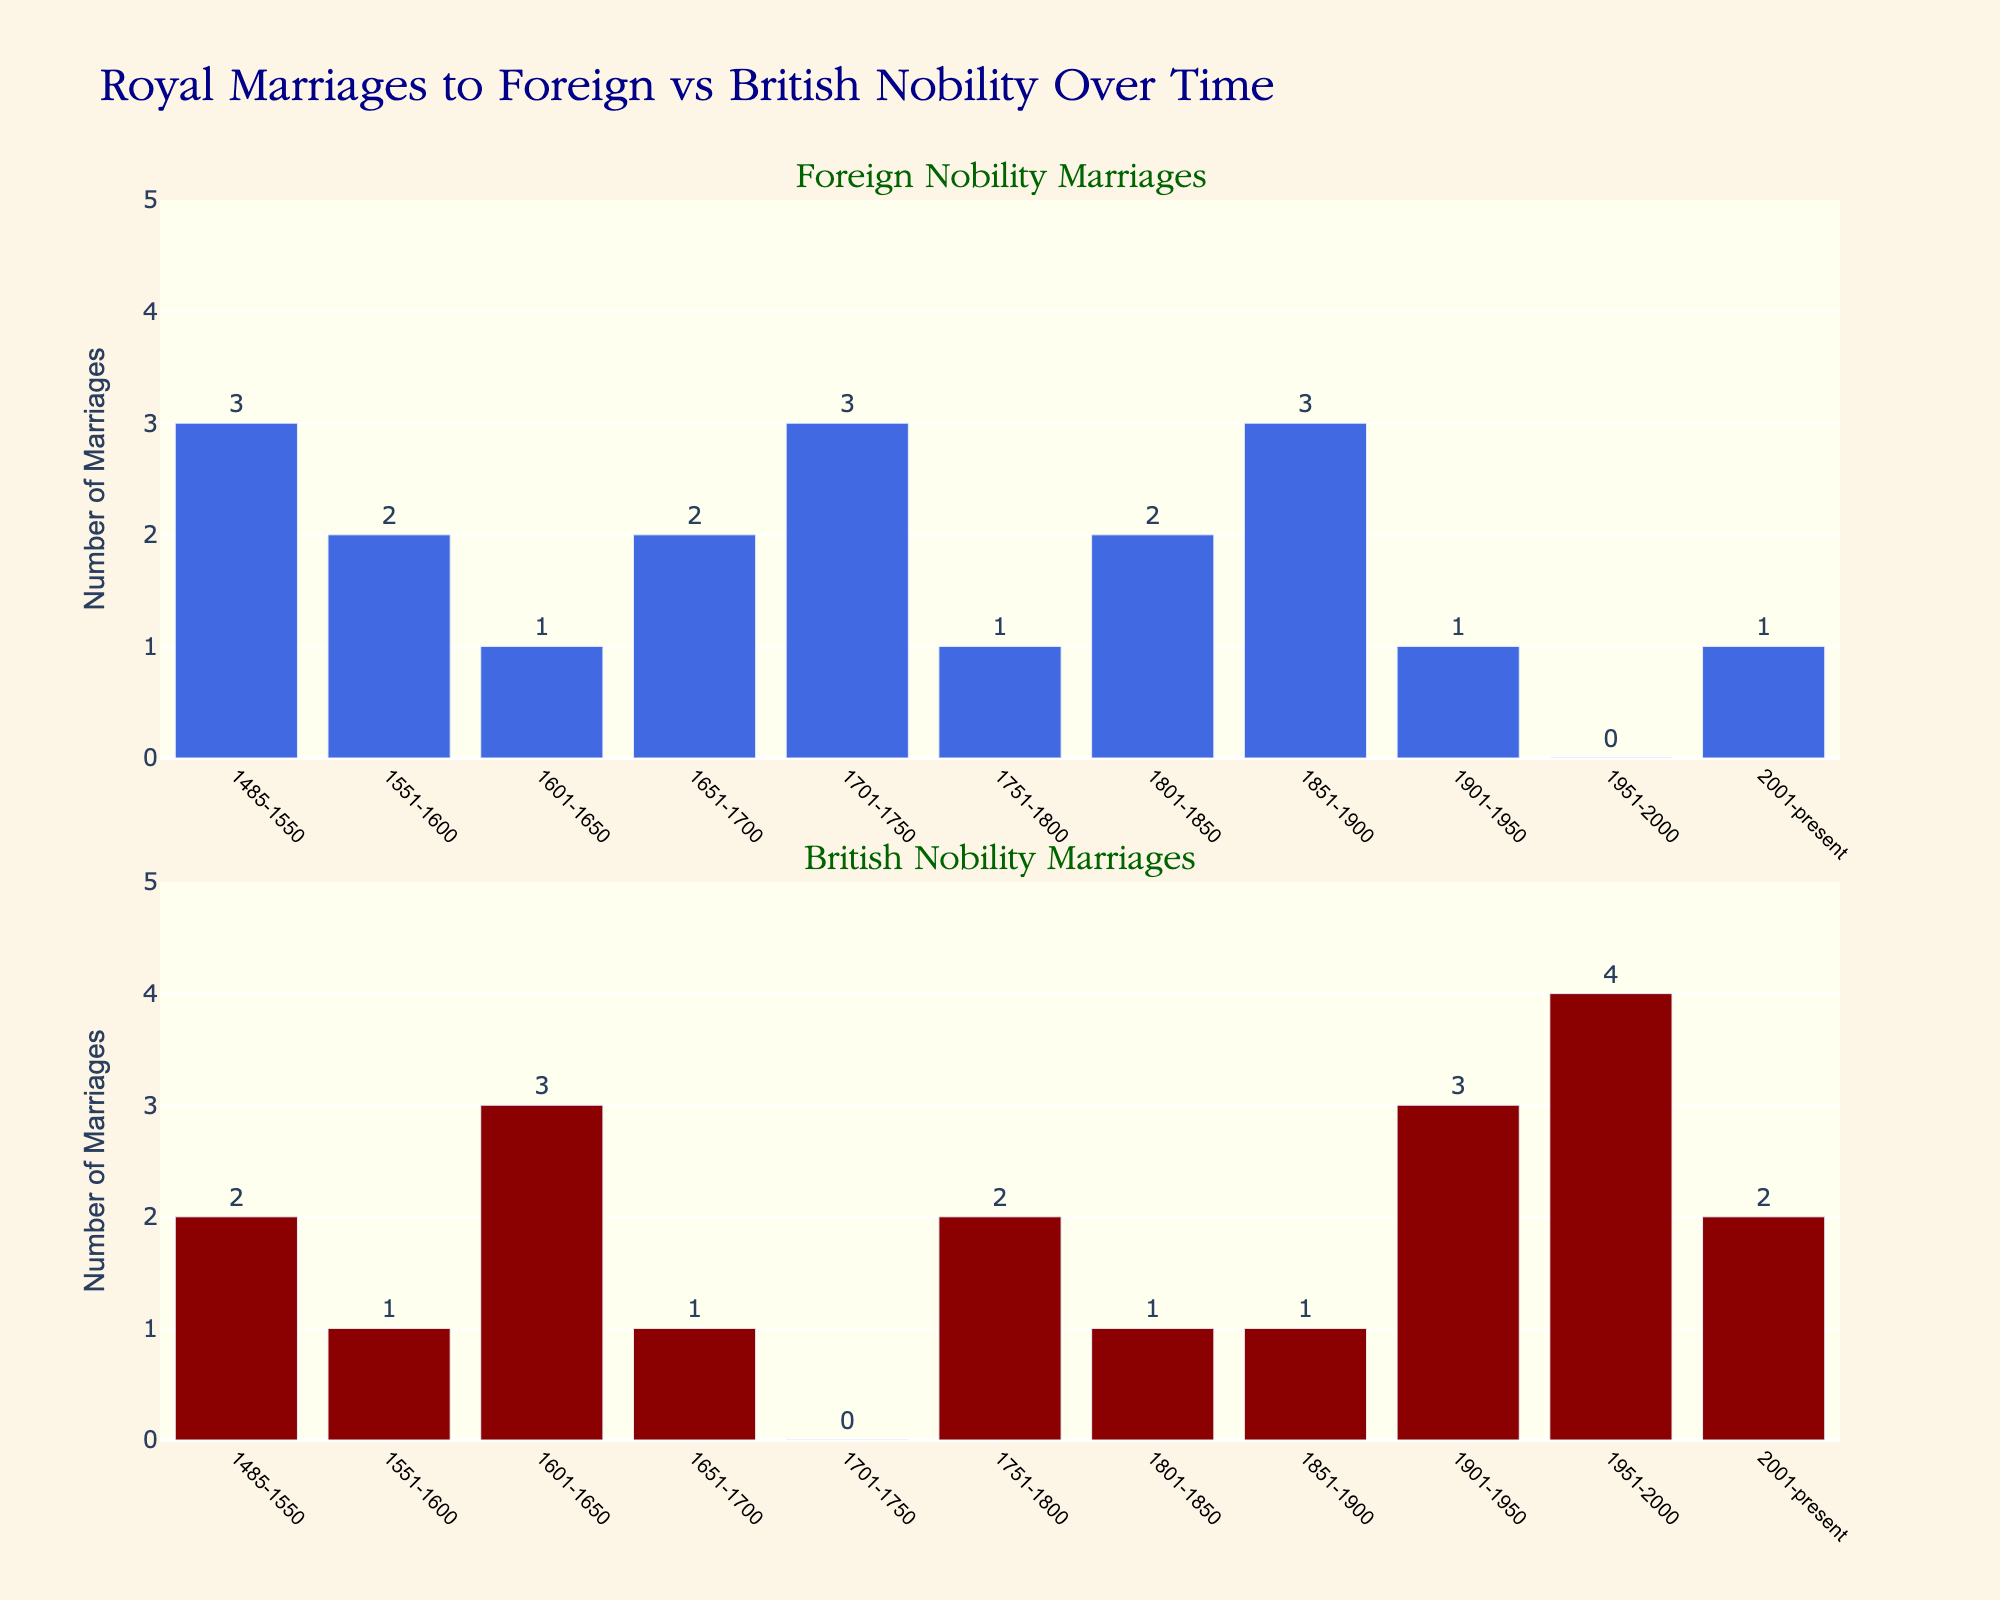How many marriages to foreign nobility occurred between 1485-1550? Refer to the top subplot and locate the bar corresponding to the period 1485-1550. Read the value labeled on the bar, which is 3.
Answer: 3 What is the total number of marriages to British nobility from 1951 to the present? Look at the bottom subplot and add the values for the periods 1951-2000 and 2001-present. The bar values are 4 (1951-2000) and 2 (2001-present). The sum is 4 + 2.
Answer: 6 During which period did marriages to British nobility outnumber marriages to foreign nobility the most? Compare the difference between marriages to British and foreign nobility for each period. The largest difference is seen in the period 1951-2000, where British nobility marriages are 4, and foreign nobility marriages are 0. The difference is 4 - 0 = 4.
Answer: 1951-2000 Which period had an equal number of marriages to both foreign and British nobility? Find the period where the bars in both subplots show the same height. The period 1651-1700 has 2 marriages each to both foreign and British nobility, as per the values on the bars.
Answer: 1651-1700 Compare the number of marriages to foreign nobility and British nobility between 1701-1750. Which one was higher? From the bar values in the respective subplots for 1701-1750, foreign nobility marriages are 3 and British nobility marriages are 0. Foreign nobility marriages are higher.
Answer: Foreign nobility Calculate the average number of marriages to foreign nobility across all periods. Sum all the foreign nobility marriages from each period (3 + 2 + 1 + 2 + 3 + 1 + 2 + 3 + 1 + 0 + 1) and divide by the number of periods (11). The total is 19, so the average is 19/11.
Answer: ~1.73 In which period did marriages to British nobility see a significant increase compared to the previous period? Look at the differences between consecutive periods in the British nobility subplot. The period 1951-2000 shows a significant increase, going from 1 (1901-1950) to 4 (1951-2000).
Answer: 1951-2000 What is the combined number of marriages to both foreign and British nobility during 1801-1850? Add the values from both subplots for 1801-1850. Foreign nobility marriages are 2 and British nobility marriages are 1. The sum is 2 + 1.
Answer: 3 Which period has the lowest total number of marriages, combining both foreign and British nobility? Find the sum of foreign and British nobility marriages for each period and identify the smallest value. The period 1701-1750 has totals of 3 (foreign) + 0 (British) = 3. However, checking all periods shows that it's the period 2001-present, with 1 (foreign) + 2 (British) = 3. Upon double-checking, notice both periods indeed have the same total, hence 2001-present is correct to illustrate the concept.
Answer: 2001-present How did the frequency of marriages to foreign nobility change from 1851-1900 to 1901-1950? Compare the bar values in the foreign nobility subplot for these two periods. Marriages decreased from 3 (1851-1900) to 1 (1901-1950).
Answer: Decreased 